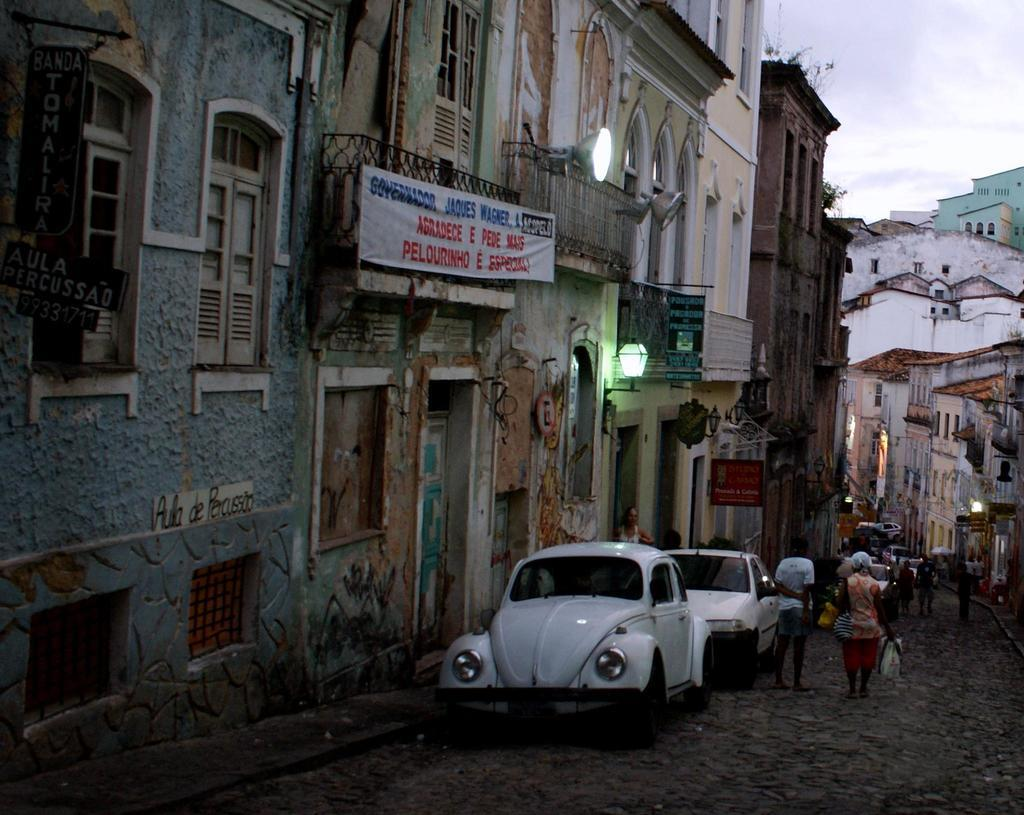What is happening on the road in the image? There are cars on a road in the image. What else can be seen in the image besides the cars? People are walking in the image, and there are houses on either side of the road. What can be seen in the background of the image? The sky is visible in the background of the image. Can you see a fight between people in the image? There is no fight between people visible in the image; people are simply walking. What type of needle is being used by the person in the image? There is no needle present in the image. 